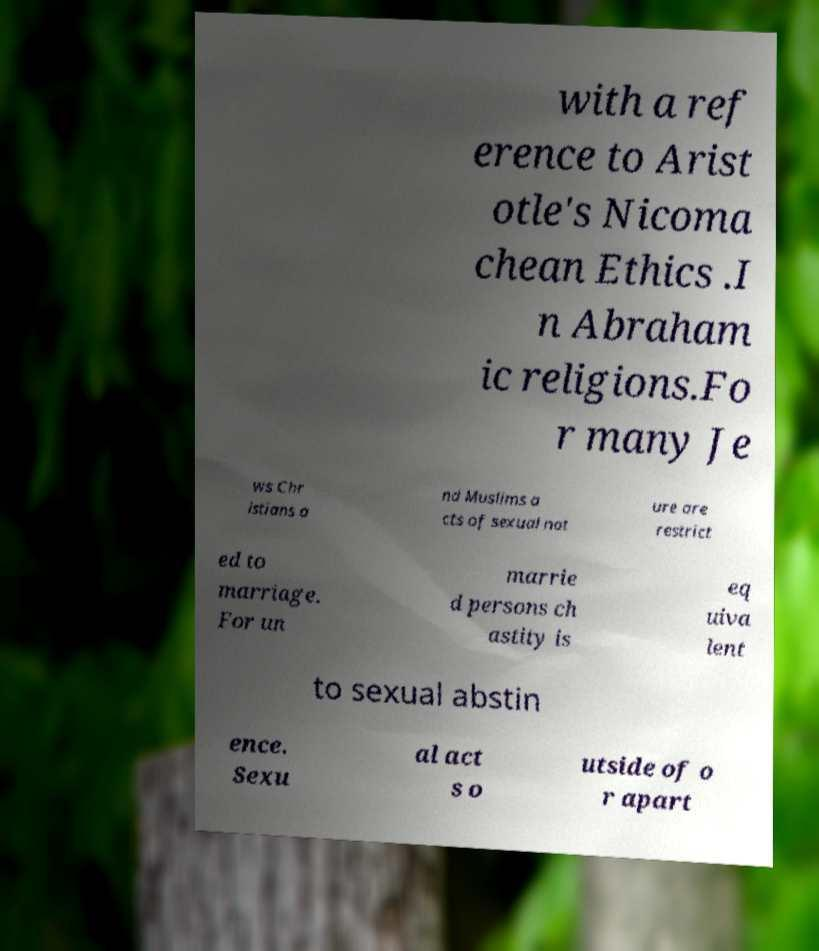Please read and relay the text visible in this image. What does it say? with a ref erence to Arist otle's Nicoma chean Ethics .I n Abraham ic religions.Fo r many Je ws Chr istians a nd Muslims a cts of sexual nat ure are restrict ed to marriage. For un marrie d persons ch astity is eq uiva lent to sexual abstin ence. Sexu al act s o utside of o r apart 